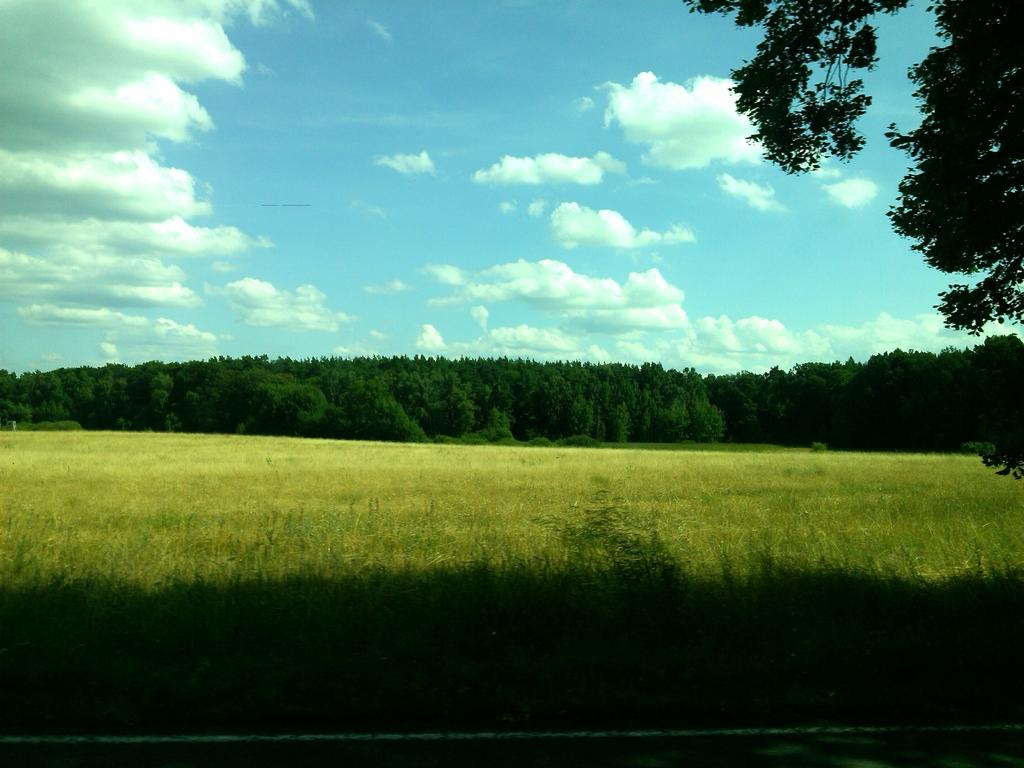What is the color of the grass in the image? The land in the image is covered with green grass. What type of vegetation is present in the image? There are trees in the image. What is the color of the sky in the image? The sky in the image is blue. How many feet are visible in the image? There are no feet visible in the image. What type of building can be seen in the image? There is no building present in the image. Who is the porter in the image? There is no porter present in the image. 